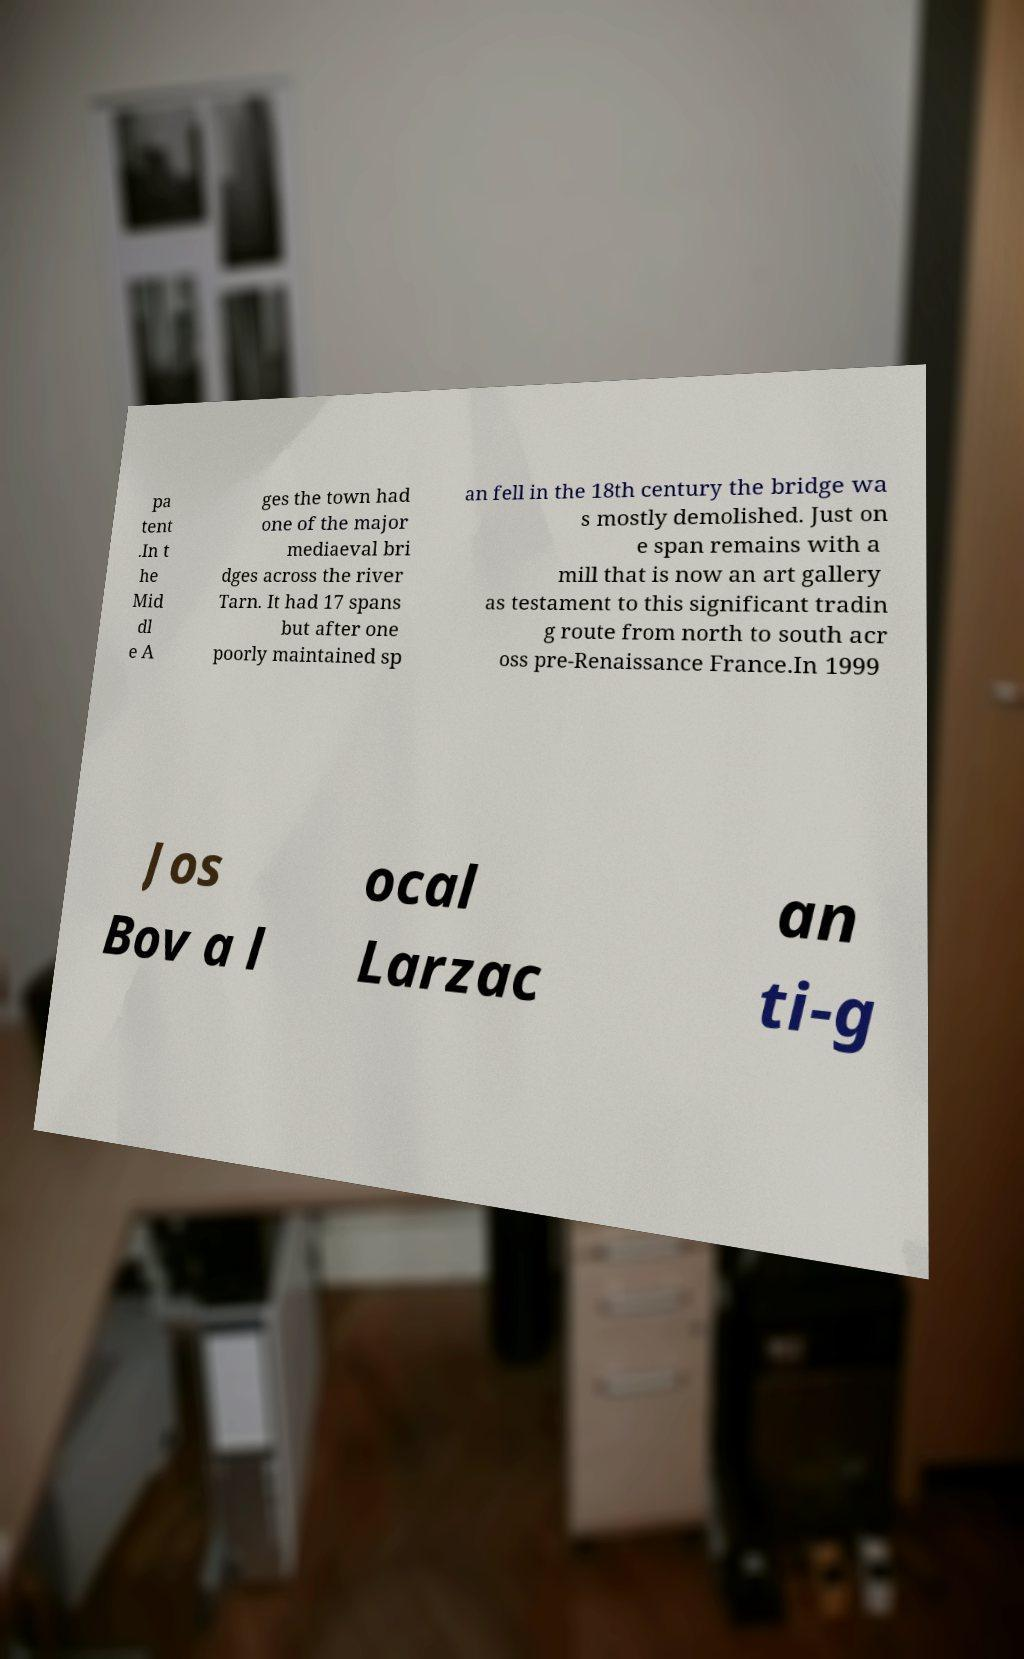Please identify and transcribe the text found in this image. pa tent .In t he Mid dl e A ges the town had one of the major mediaeval bri dges across the river Tarn. It had 17 spans but after one poorly maintained sp an fell in the 18th century the bridge wa s mostly demolished. Just on e span remains with a mill that is now an art gallery as testament to this significant tradin g route from north to south acr oss pre-Renaissance France.In 1999 Jos Bov a l ocal Larzac an ti-g 